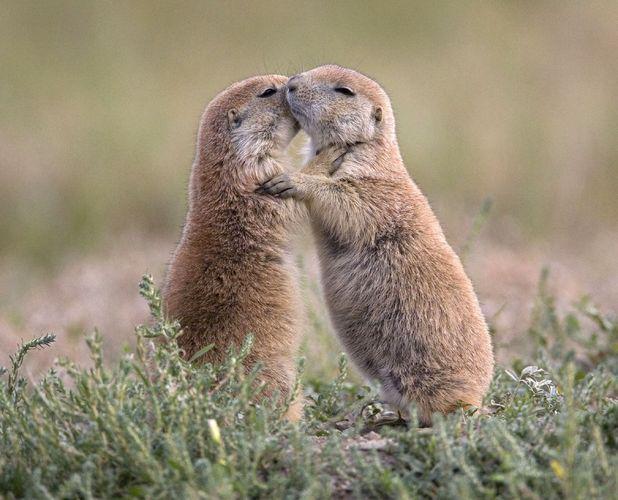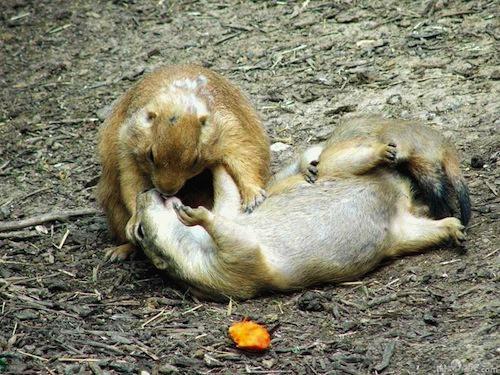The first image is the image on the left, the second image is the image on the right. Examine the images to the left and right. Is the description "The animals are facing each other in both images." accurate? Answer yes or no. Yes. The first image is the image on the left, the second image is the image on the right. Assess this claim about the two images: "There is a total of 4 prairie dogs.". Correct or not? Answer yes or no. No. 